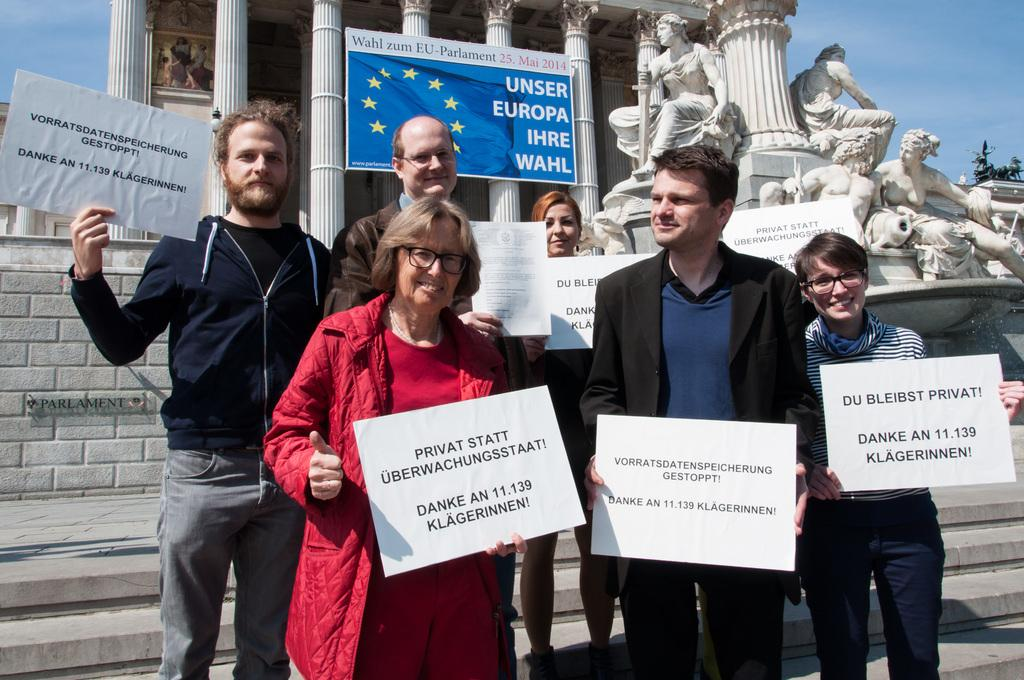How many people are present in the image? There are six persons standing in the image. What are the persons holding in the image? The persons are holding boards. What other objects or structures can be seen in the image? There are sculptures and a building with pillars in the image. What can be seen in the background of the image? The sky is visible in the background of the image. What type of discussion is taking place between the persons holding the boards in the image? There is no indication of a discussion taking place in the image; the persons are simply holding boards. How many snakes can be seen slithering around the sculptures in the image? There are no snakes present in the image; it features sculptures and people holding boards. 